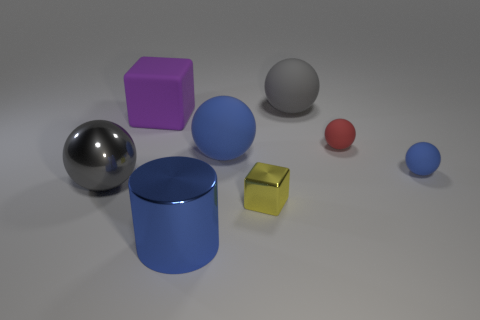Is the color of the large matte ball in front of the gray rubber ball the same as the small shiny thing?
Your response must be concise. No. The other shiny object that is the same shape as the red thing is what color?
Offer a very short reply. Gray. How many large objects are either metal things or red cubes?
Your answer should be very brief. 2. What size is the gray ball that is in front of the large gray rubber sphere?
Ensure brevity in your answer.  Large. Is there a big ball that has the same color as the big cube?
Ensure brevity in your answer.  No. Is the color of the small metal cube the same as the metallic ball?
Your response must be concise. No. The large matte object that is the same color as the metallic sphere is what shape?
Ensure brevity in your answer.  Sphere. How many large rubber things are to the left of the matte ball to the left of the small cube?
Offer a very short reply. 1. How many tiny objects have the same material as the big cube?
Your response must be concise. 2. Are there any large purple matte objects to the right of the tiny shiny object?
Provide a short and direct response. No. 